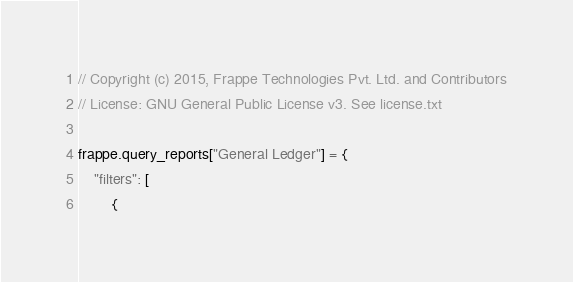<code> <loc_0><loc_0><loc_500><loc_500><_JavaScript_>// Copyright (c) 2015, Frappe Technologies Pvt. Ltd. and Contributors
// License: GNU General Public License v3. See license.txt

frappe.query_reports["General Ledger"] = {
	"filters": [
		{</code> 